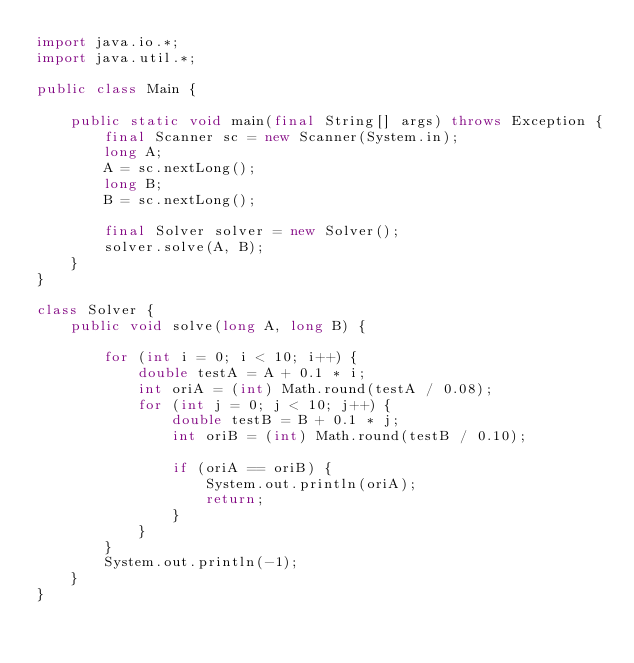Convert code to text. <code><loc_0><loc_0><loc_500><loc_500><_Java_>import java.io.*;
import java.util.*;

public class Main {

    public static void main(final String[] args) throws Exception {
        final Scanner sc = new Scanner(System.in);
        long A;
        A = sc.nextLong();
        long B;
        B = sc.nextLong();

        final Solver solver = new Solver();
        solver.solve(A, B);
    }
}

class Solver {
    public void solve(long A, long B) {

        for (int i = 0; i < 10; i++) {
            double testA = A + 0.1 * i;
            int oriA = (int) Math.round(testA / 0.08);
            for (int j = 0; j < 10; j++) {
                double testB = B + 0.1 * j;
                int oriB = (int) Math.round(testB / 0.10);

                if (oriA == oriB) {
                    System.out.println(oriA);
                    return;
                }
            }
        }
        System.out.println(-1);
    }
}

</code> 